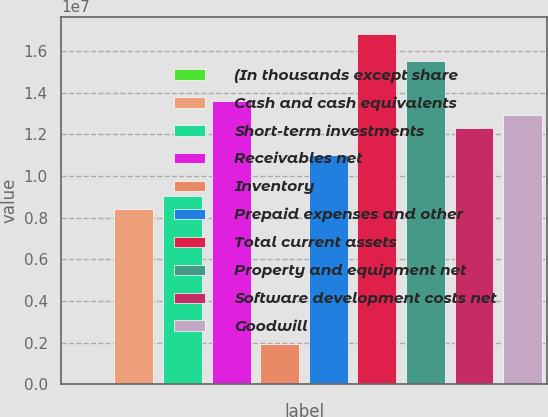Convert chart to OTSL. <chart><loc_0><loc_0><loc_500><loc_500><bar_chart><fcel>(In thousands except share<fcel>Cash and cash equivalents<fcel>Short-term investments<fcel>Receivables net<fcel>Inventory<fcel>Prepaid expenses and other<fcel>Total current assets<fcel>Property and equipment net<fcel>Software development costs net<fcel>Goodwill<nl><fcel>2017<fcel>8.4095e+06<fcel>9.05623e+06<fcel>1.35833e+07<fcel>1.94221e+06<fcel>1.09964e+07<fcel>1.6817e+07<fcel>1.55235e+07<fcel>1.22899e+07<fcel>1.29366e+07<nl></chart> 